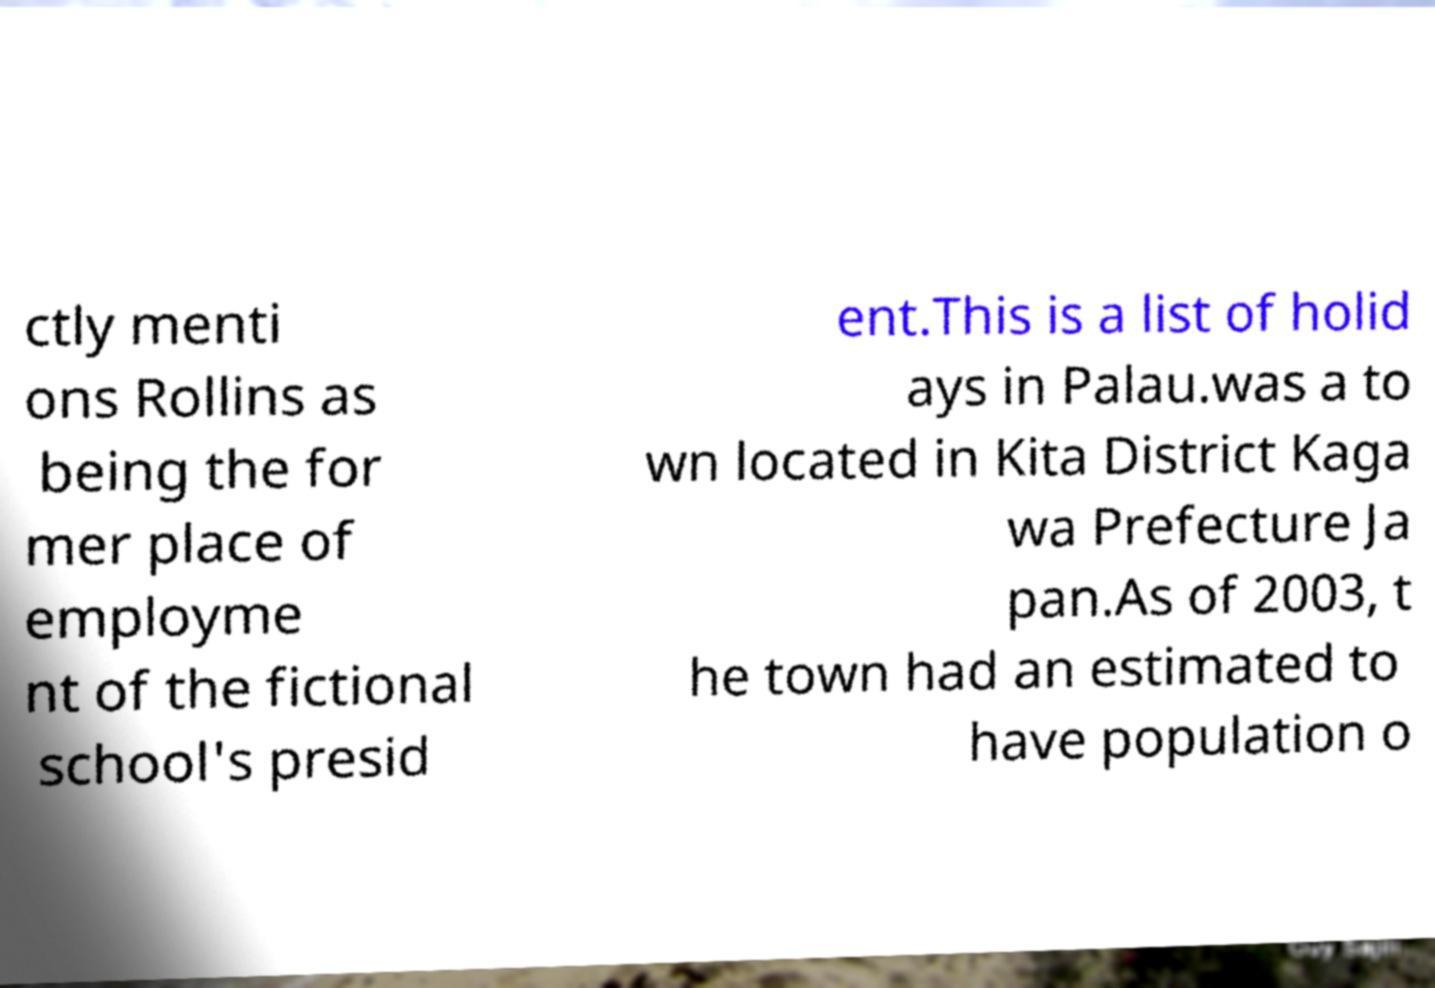Could you assist in decoding the text presented in this image and type it out clearly? ctly menti ons Rollins as being the for mer place of employme nt of the fictional school's presid ent.This is a list of holid ays in Palau.was a to wn located in Kita District Kaga wa Prefecture Ja pan.As of 2003, t he town had an estimated to have population o 